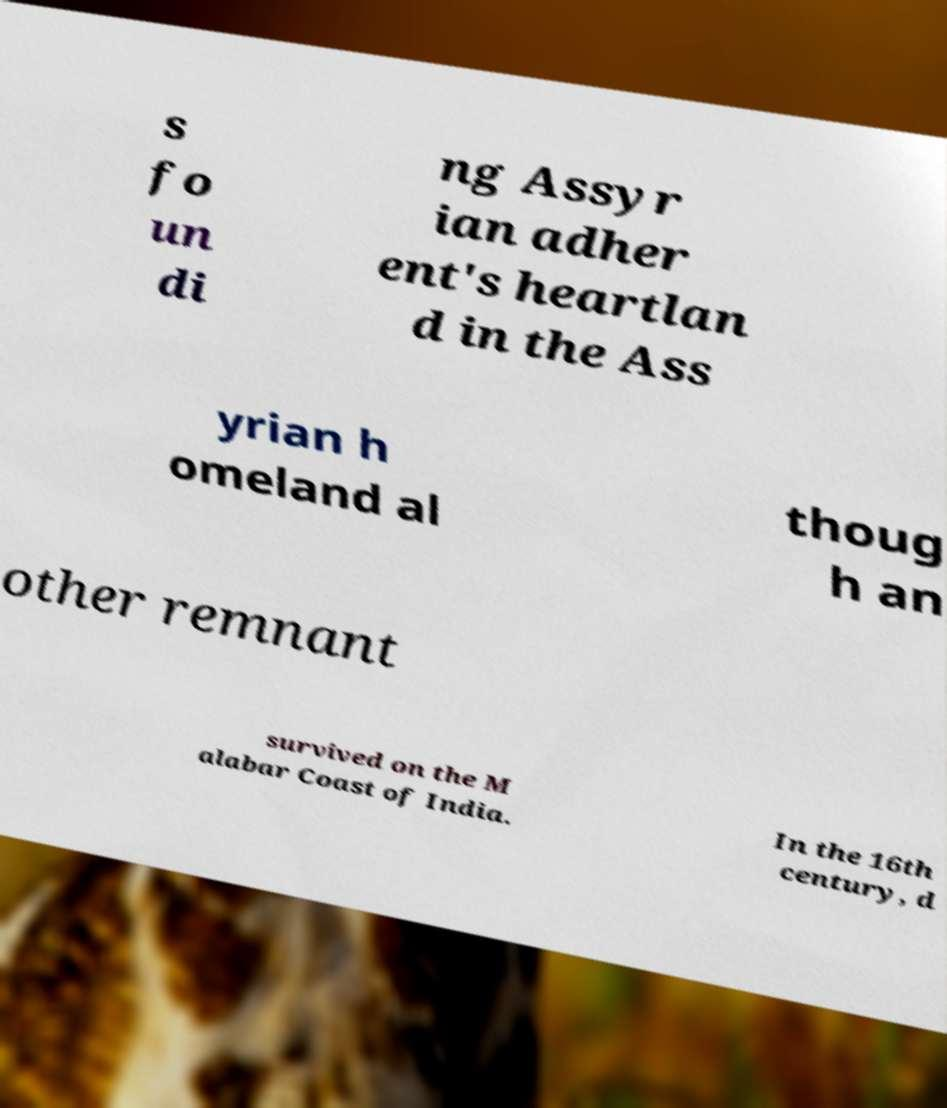Could you assist in decoding the text presented in this image and type it out clearly? s fo un di ng Assyr ian adher ent's heartlan d in the Ass yrian h omeland al thoug h an other remnant survived on the M alabar Coast of India. In the 16th century, d 